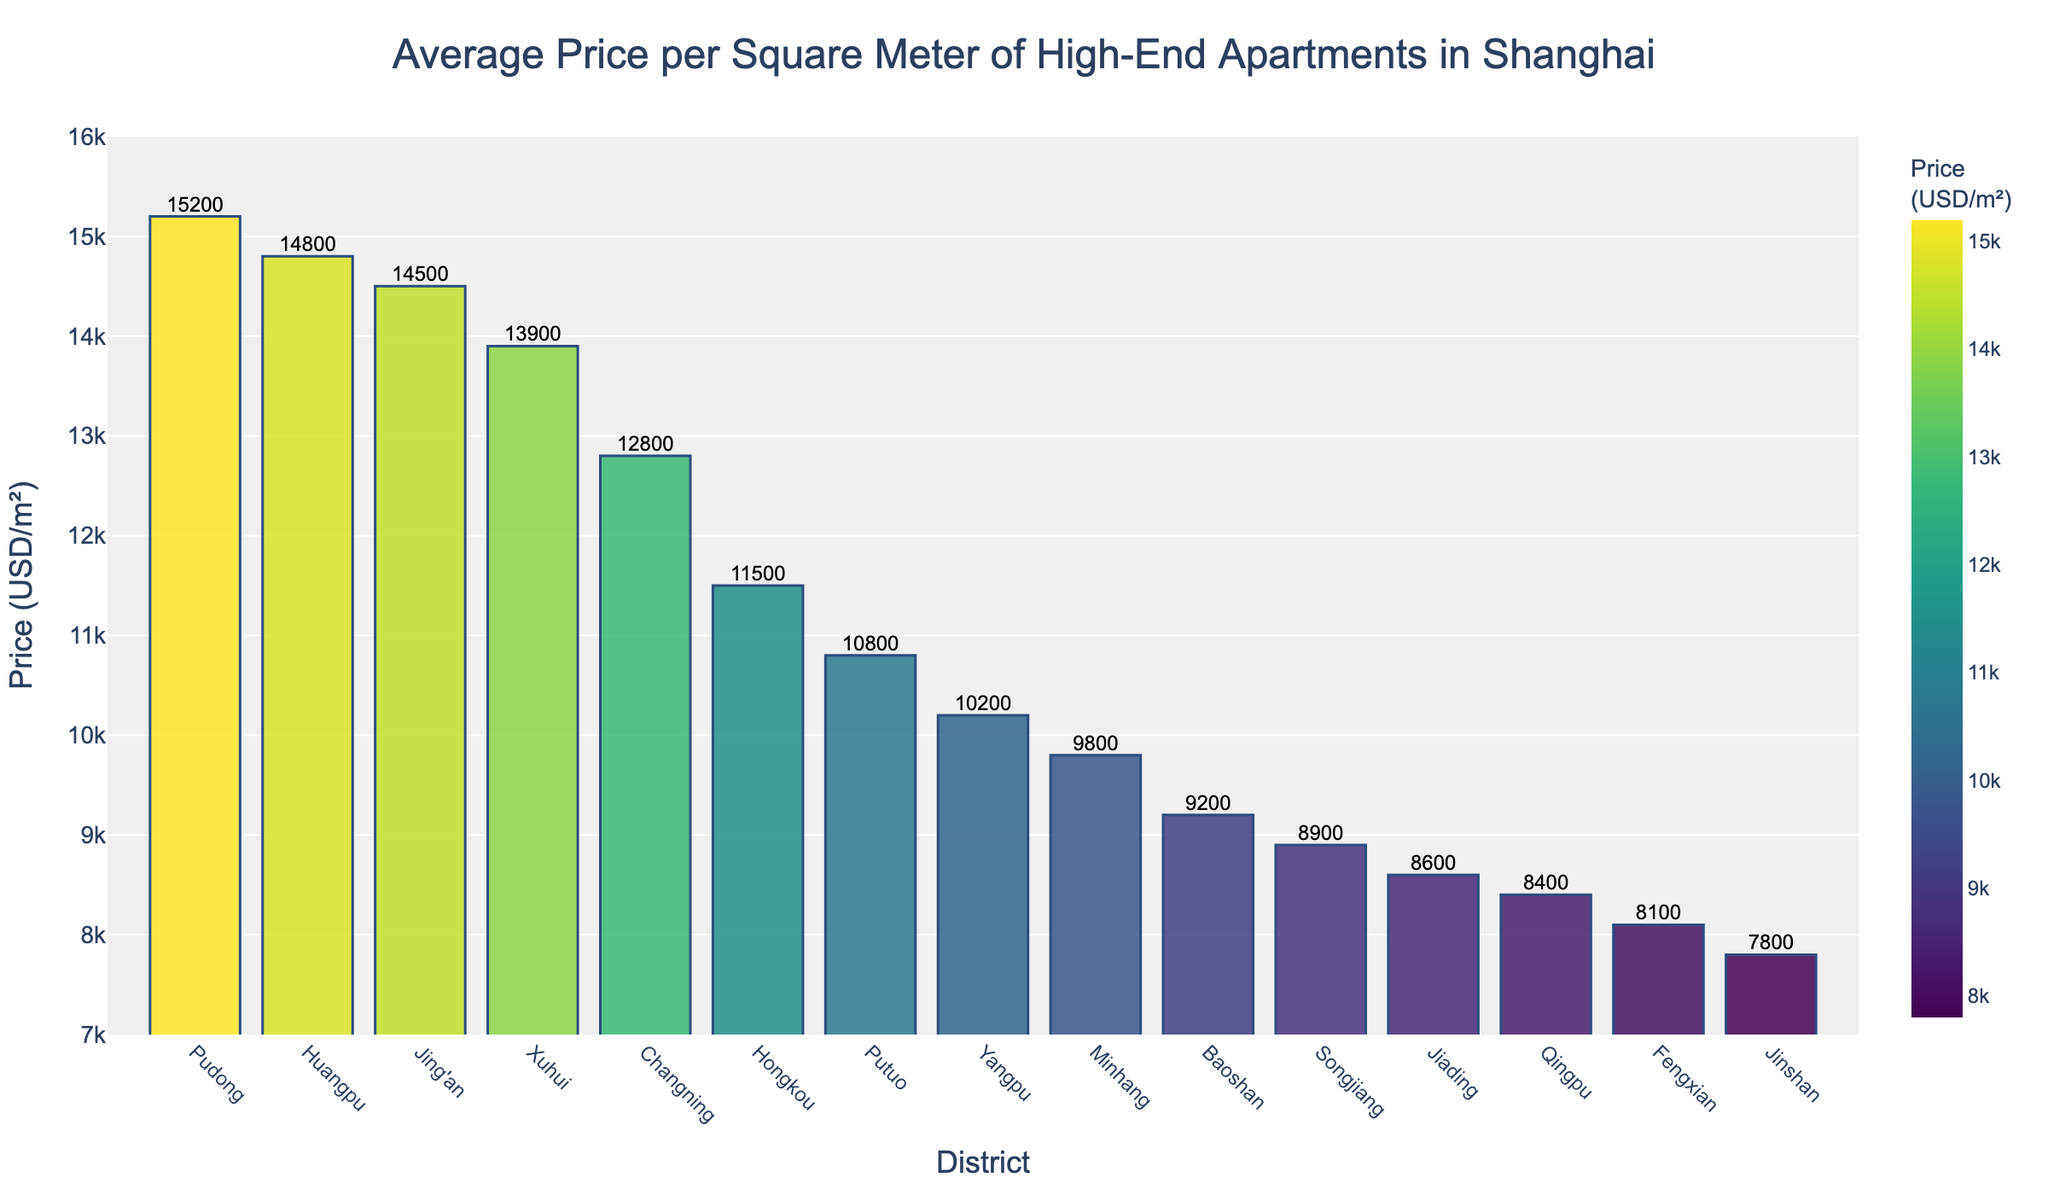Which district has the highest average price per square meter? The highest bar in the bar chart represents the district with the highest average price per square meter.
Answer: Pudong Which district has the lowest average price per square meter? The lowest bar in the bar chart represents the district with the lowest average price per square meter.
Answer: Jinshan What is the approximate difference in price per square meter between Pudong and Huangpu? Subtract the average price per square meter in Huangpu from that in Pudong (15200 - 14800).
Answer: 400 USD/m² How many districts have an average price per square meter above 10,000 USD? Count the number of bars (districts) whose height corresponds to an average price per square meter above 10,000 USD.
Answer: 7 Which districts have an average price per square meter between 13,000 and 15,000 USD? Identify the bars whose height represents an average price per square meter between 13,000 and 15,000 USD.
Answer: Xuhui, Jing'an, Huangpu What is the range of average prices per square meter in the chart? Subtract the lowest average price per square meter from the highest average price per square meter (15200 - 7800).
Answer: 7400 USD/m² Is there a significant color gradient difference between the districts' prices? Observe the color variation in the bars; a noticeable gradient difference would indicate varying prices.
Answer: Yes What is the total of the average prices per square meter for Pudong, Huangpu, and Jing'an combined? Sum the average prices per square meter for Pudong (15200), Huangpu (14800), and Jing'an (14500).
Answer: 44500 USD/m² Which district has a price per square meter closest to 10,000 USD? Identify the bar that is closest to the height representing 10,000 USD.
Answer: Yangpu How much higher is the average price per square meter in Pudong compared to Minhang? Subtract the average price per square meter in Minhang from that in Pudong (15200 - 9800).
Answer: 5400 USD/m² 